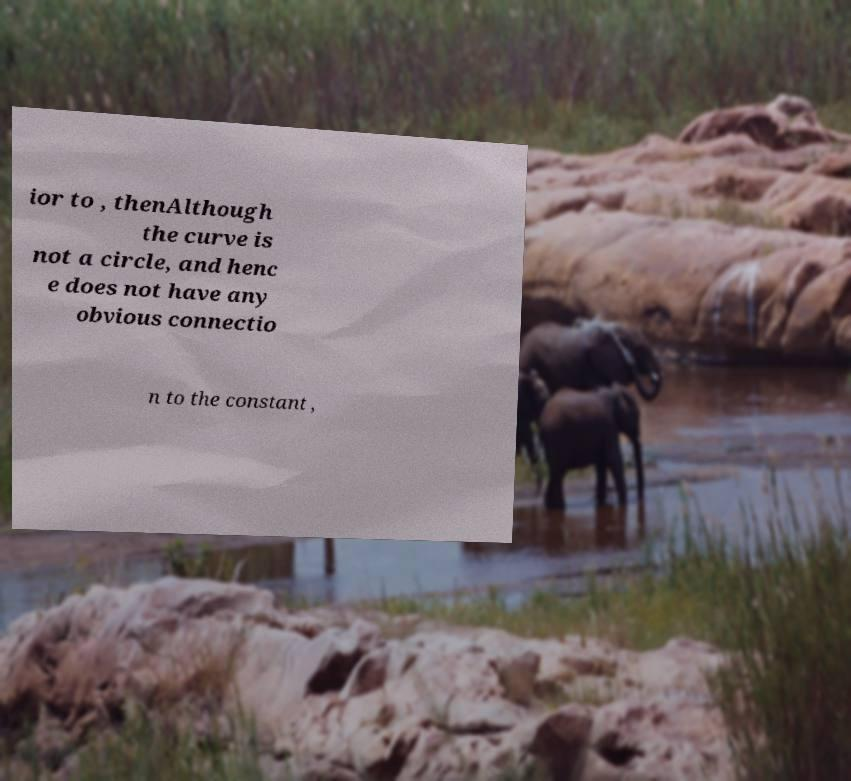What messages or text are displayed in this image? I need them in a readable, typed format. ior to , thenAlthough the curve is not a circle, and henc e does not have any obvious connectio n to the constant , 